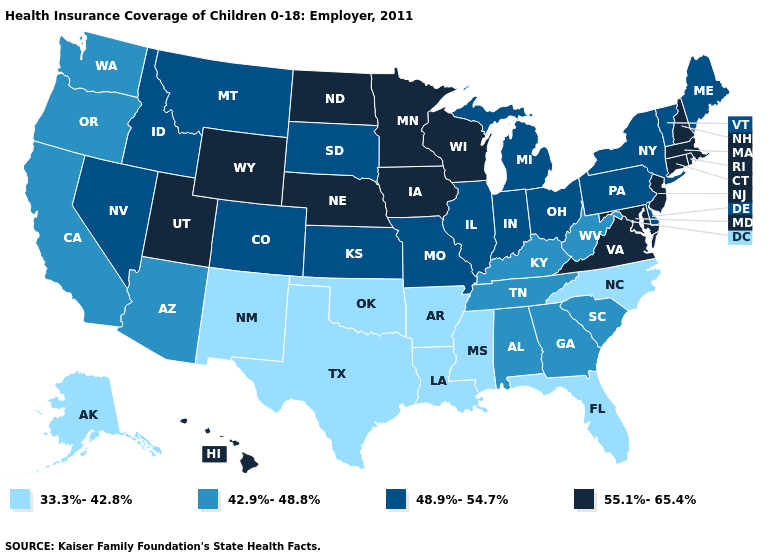Which states hav the highest value in the MidWest?
Give a very brief answer. Iowa, Minnesota, Nebraska, North Dakota, Wisconsin. Among the states that border Michigan , which have the lowest value?
Concise answer only. Indiana, Ohio. What is the value of New York?
Give a very brief answer. 48.9%-54.7%. What is the highest value in the USA?
Be succinct. 55.1%-65.4%. Does the map have missing data?
Be succinct. No. Name the states that have a value in the range 48.9%-54.7%?
Be succinct. Colorado, Delaware, Idaho, Illinois, Indiana, Kansas, Maine, Michigan, Missouri, Montana, Nevada, New York, Ohio, Pennsylvania, South Dakota, Vermont. Name the states that have a value in the range 33.3%-42.8%?
Concise answer only. Alaska, Arkansas, Florida, Louisiana, Mississippi, New Mexico, North Carolina, Oklahoma, Texas. Does the first symbol in the legend represent the smallest category?
Concise answer only. Yes. What is the value of New York?
Write a very short answer. 48.9%-54.7%. Does Connecticut have the same value as Nebraska?
Give a very brief answer. Yes. Among the states that border Utah , which have the highest value?
Write a very short answer. Wyoming. Does Nebraska have the same value as Mississippi?
Write a very short answer. No. Among the states that border Washington , which have the highest value?
Quick response, please. Idaho. What is the value of Maryland?
Keep it brief. 55.1%-65.4%. 